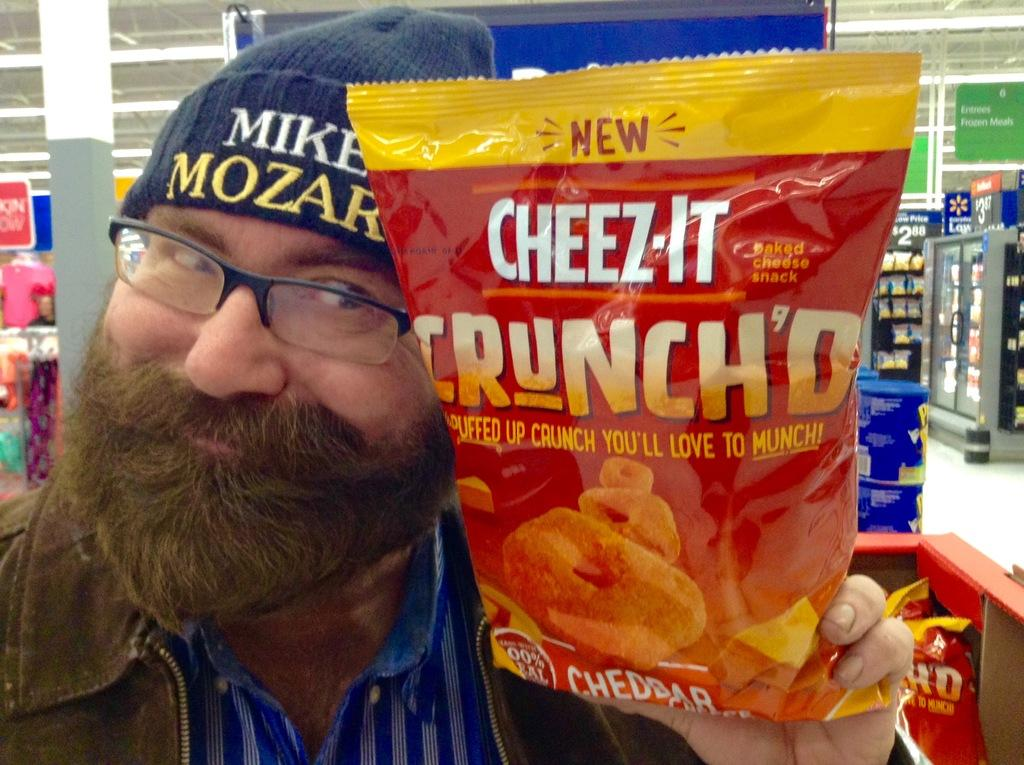What is the person holding in the image? The person is holding a chips packet in the image. What can be seen in the background of the image? In the background of the image, there are boxes, clothes, pillars, lights, boards, packets in the refrigerator, and racks. Can you describe the surroundings of the person? The person is surrounded by various objects and structures, including pillars, lights, and racks. What type of air can be seen flowing around the person in the image? There is no air flow visible in the image; it is a still photograph. Can you describe the icicles hanging from the pillars in the image? There are no icicles present in the image; the pillars are not depicted as having any ice formations. 